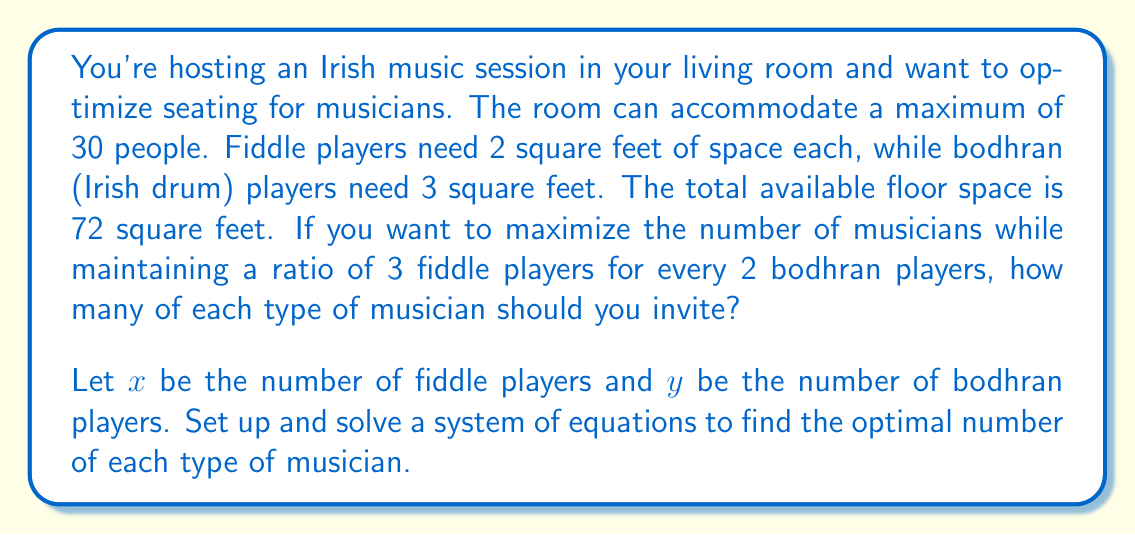Can you solve this math problem? Let's approach this step-by-step:

1) First, we need to set up our system of equations based on the given information:

   Equation 1 (Total people): $x + y = 30$
   Equation 2 (Floor space): $2x + 3y = 72$
   Equation 3 (Ratio): $\frac{x}{3} = \frac{y}{2}$ or $2x = 3y$

2) We can solve this using substitution. From Equation 3, we can express $x$ in terms of $y$:
   
   $x = \frac{3y}{2}$

3) Substitute this into Equation 1:

   $\frac{3y}{2} + y = 30$
   $\frac{3y}{2} + \frac{2y}{2} = 30$
   $\frac{5y}{2} = 30$
   $y = 12$

4) Now we can find $x$ by substituting $y = 12$ into the expression from step 2:

   $x = \frac{3(12)}{2} = 18$

5) Let's verify that this solution satisfies all our conditions:

   - Total people: $18 + 12 = 30$ ✓
   - Floor space: $2(18) + 3(12) = 36 + 36 = 72$ ✓
   - Ratio: $\frac{18}{3} = \frac{12}{2} = 6$ ✓

Therefore, the optimal arrangement is 18 fiddle players and 12 bodhran players.
Answer: 18 fiddle players, 12 bodhran players 